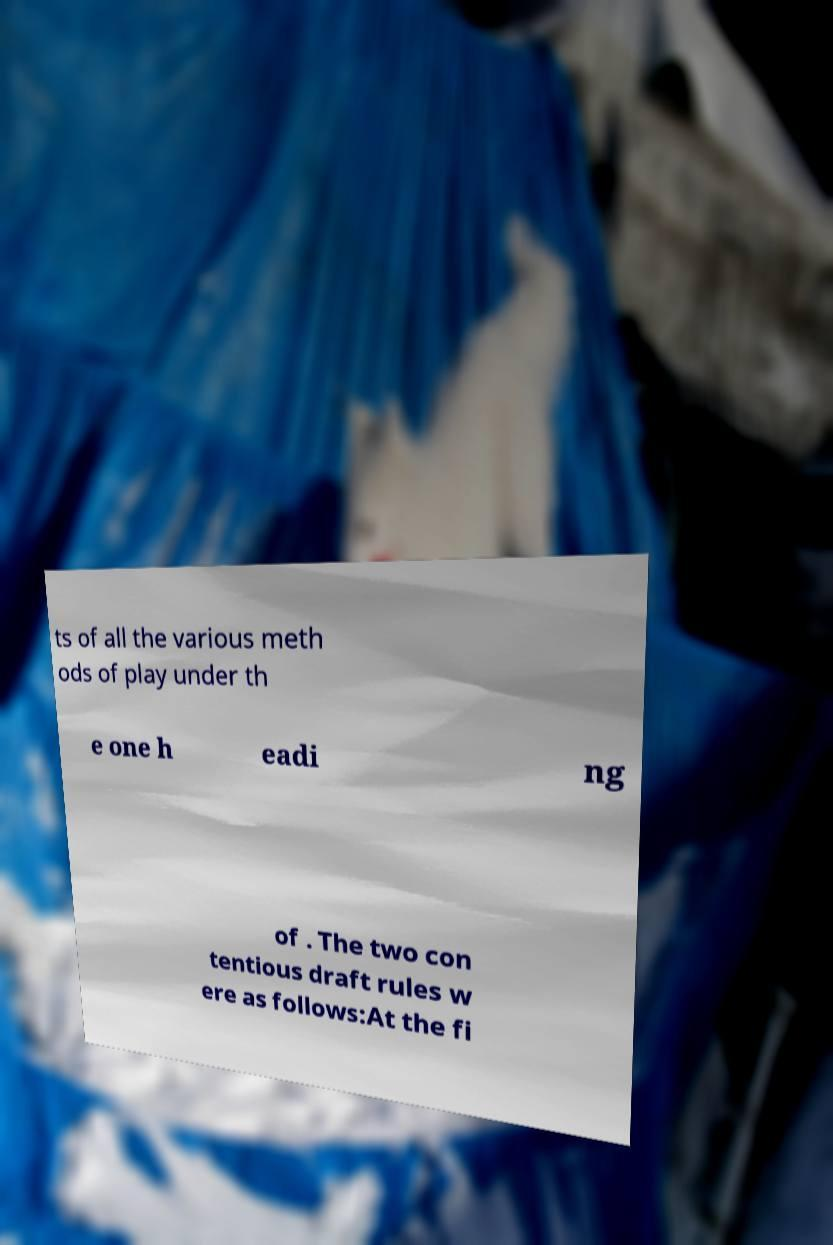Could you assist in decoding the text presented in this image and type it out clearly? ts of all the various meth ods of play under th e one h eadi ng of . The two con tentious draft rules w ere as follows:At the fi 